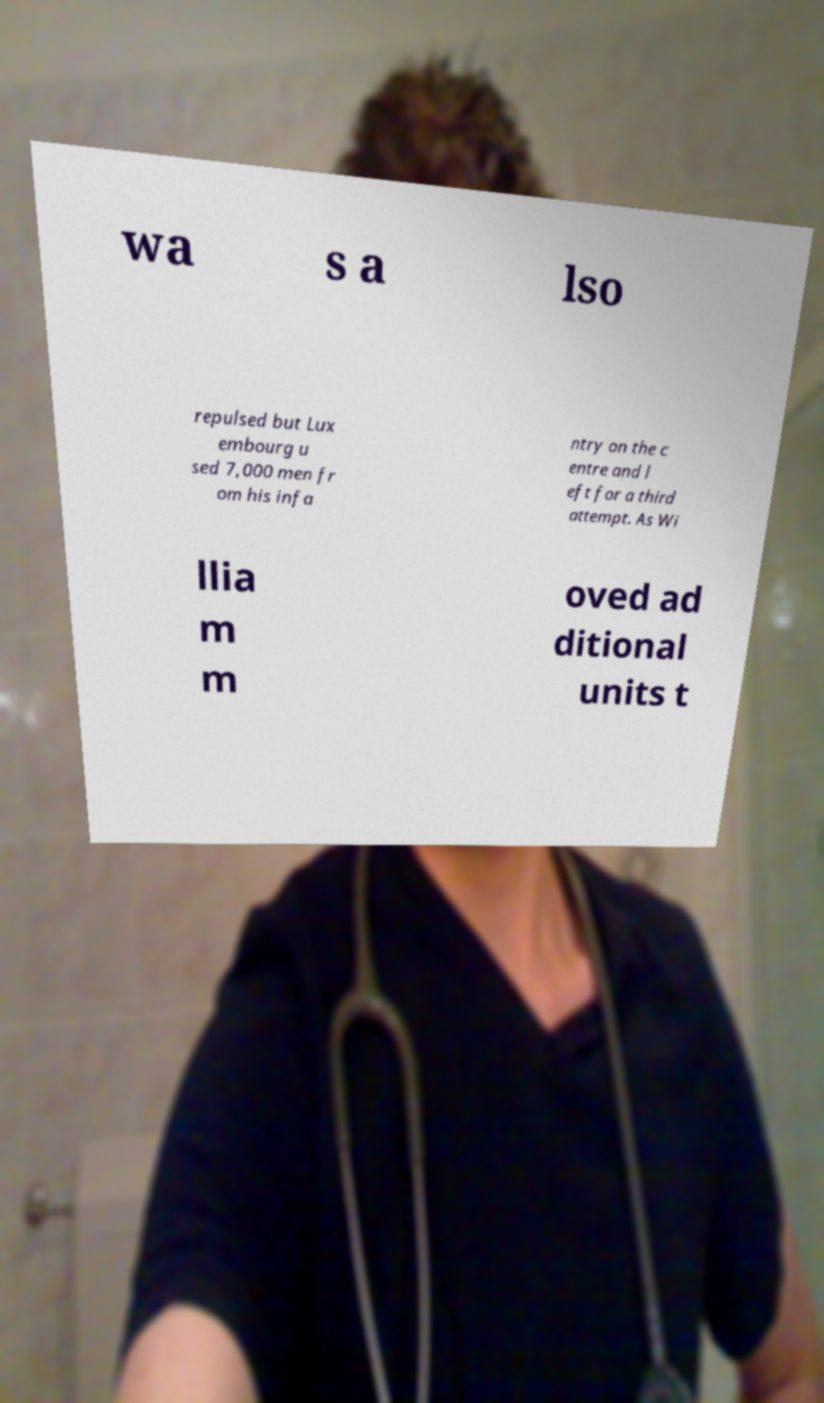Please identify and transcribe the text found in this image. wa s a lso repulsed but Lux embourg u sed 7,000 men fr om his infa ntry on the c entre and l eft for a third attempt. As Wi llia m m oved ad ditional units t 